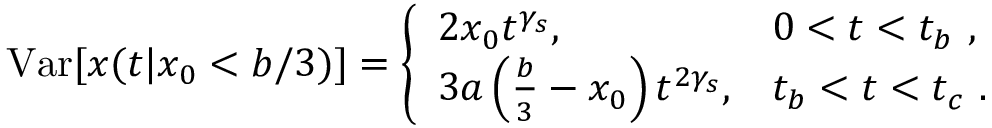Convert formula to latex. <formula><loc_0><loc_0><loc_500><loc_500>V a r [ x ( t | x _ { 0 } < b / 3 ) ] = \left \{ \begin{array} { l l } { 2 x _ { 0 } t ^ { \gamma _ { s } } , } & { 0 < t < t _ { b } \ , } \\ { 3 a \left ( \frac { b } { 3 } - x _ { 0 } \right ) t ^ { 2 \gamma _ { s } } , } & { t _ { b } < t < t _ { c } \ . } \end{array}</formula> 